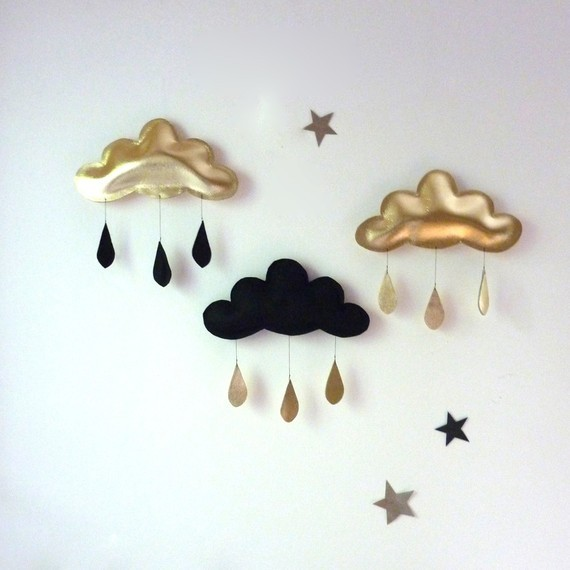What might the choice of these particular colors and materials say about the mood or atmosphere the artist is trying to convey? The use of gold and black in the clouds and their raindrops can create a sense of elegance and sophistication, with the gold elements bringing warmth and a touch of luxury to the scene. The contrasting black introduces a certain depth and gravity. These choices can evoke a mood of contemplative serenity, where viewers are invited to ponder the complexity and richness of life's experiences. The simplicity of the design, alongside the shimmer of the gold, might suggest a tranquil atmosphere with underlying themes of opulence and introspection. 